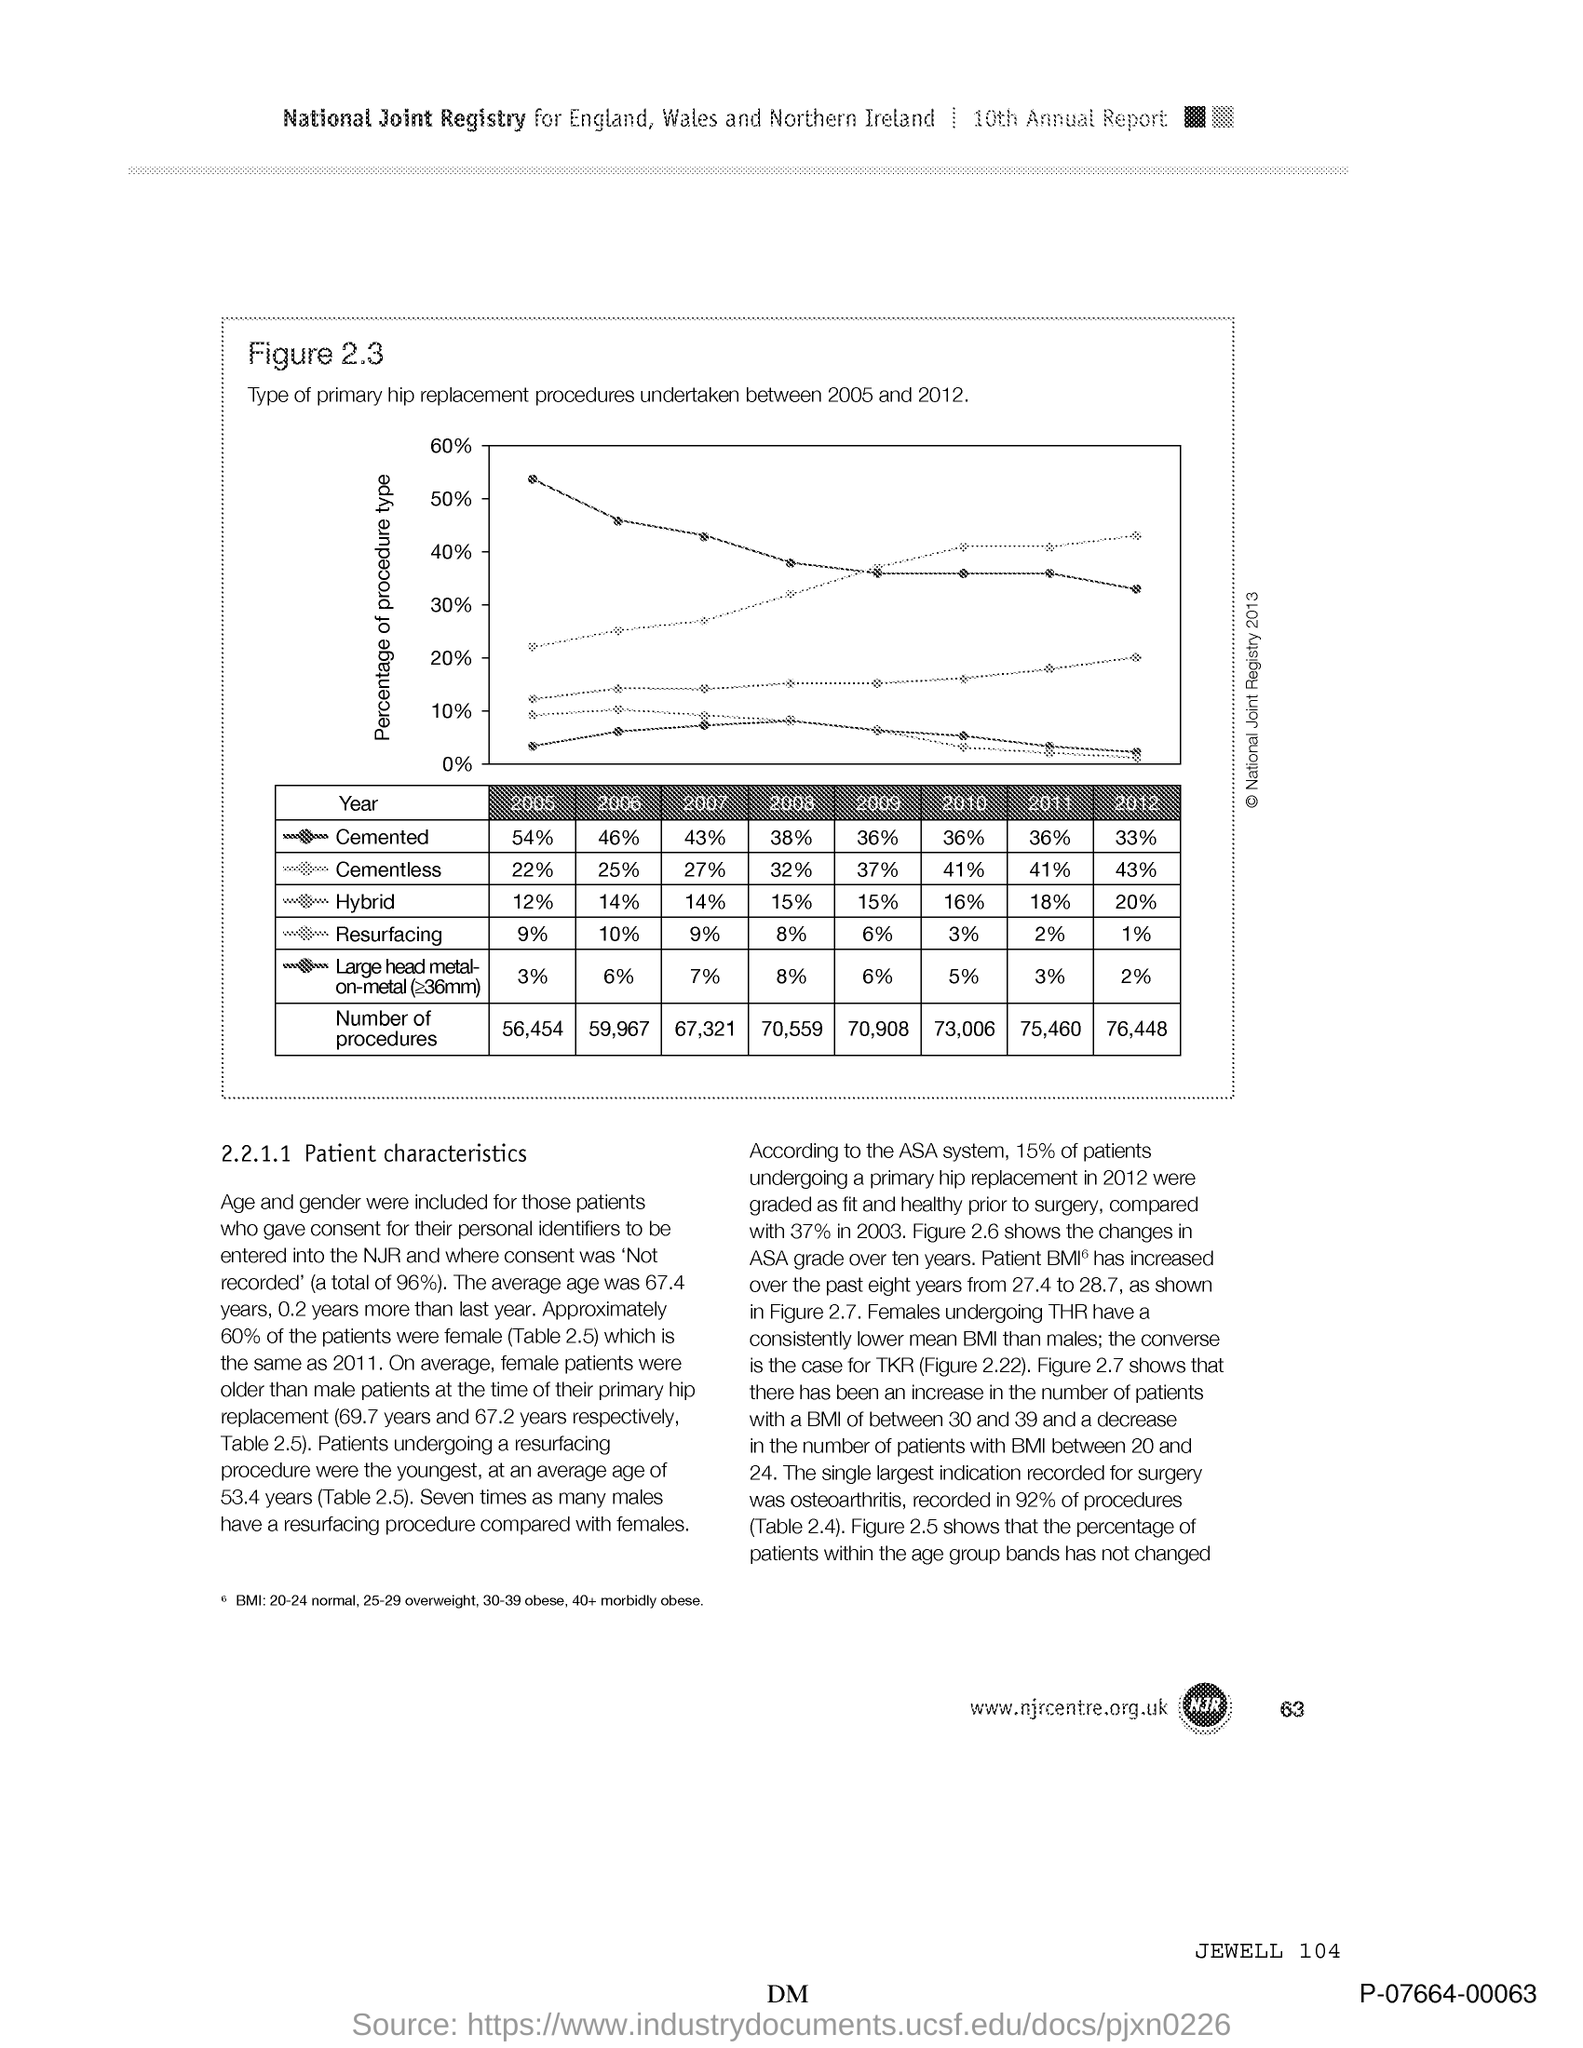What is the percentage of "cemented" in 2005?
Ensure brevity in your answer.  54%. What is the percentage of "cemented" in 2006?
Give a very brief answer. 46%. What is the percentage of "cemented" in 2007?
Keep it short and to the point. 43%. What is the percentage of "cemented" in 2008?
Ensure brevity in your answer.  38%. What is the percentage of "cemented" in 2009?
Give a very brief answer. 36%. What is the percentage of "cemented" in 2010?
Provide a short and direct response. 36%. What is the percentage of "cemented" in 2011?
Your answer should be compact. 36%. What is the percentage of "cemented" in 2012?
Your answer should be very brief. 33%. What is the percentage of "cementless" in 2005?
Your answer should be very brief. 22%. What is the percentage of "cementless" in 2006?
Give a very brief answer. 25%. 